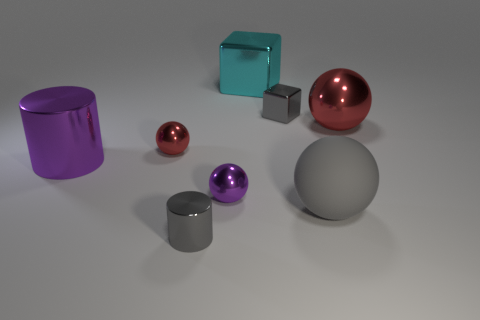There is a tiny gray thing that is left of the small shiny object to the right of the big cyan shiny cube; what is its material?
Offer a terse response. Metal. Are there any objects?
Offer a terse response. Yes. What is the size of the metallic object that is in front of the small ball in front of the large purple cylinder?
Offer a terse response. Small. Is the number of big purple metallic objects that are to the left of the large matte object greater than the number of large red metallic balls right of the big red metal ball?
Your response must be concise. Yes. What number of blocks are either small matte things or cyan metal things?
Keep it short and to the point. 1. Is the shape of the small gray metallic thing that is behind the big red shiny ball the same as  the cyan thing?
Ensure brevity in your answer.  Yes. The small shiny block has what color?
Provide a succinct answer. Gray. There is another object that is the same shape as the large purple thing; what is its color?
Offer a terse response. Gray. How many big red objects are the same shape as the large purple metallic object?
Offer a terse response. 0. What number of objects are gray spheres or large metal objects that are on the right side of the big cylinder?
Your answer should be very brief. 3. 